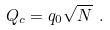<formula> <loc_0><loc_0><loc_500><loc_500>Q _ { c } = q _ { 0 } \sqrt { N } \ .</formula> 